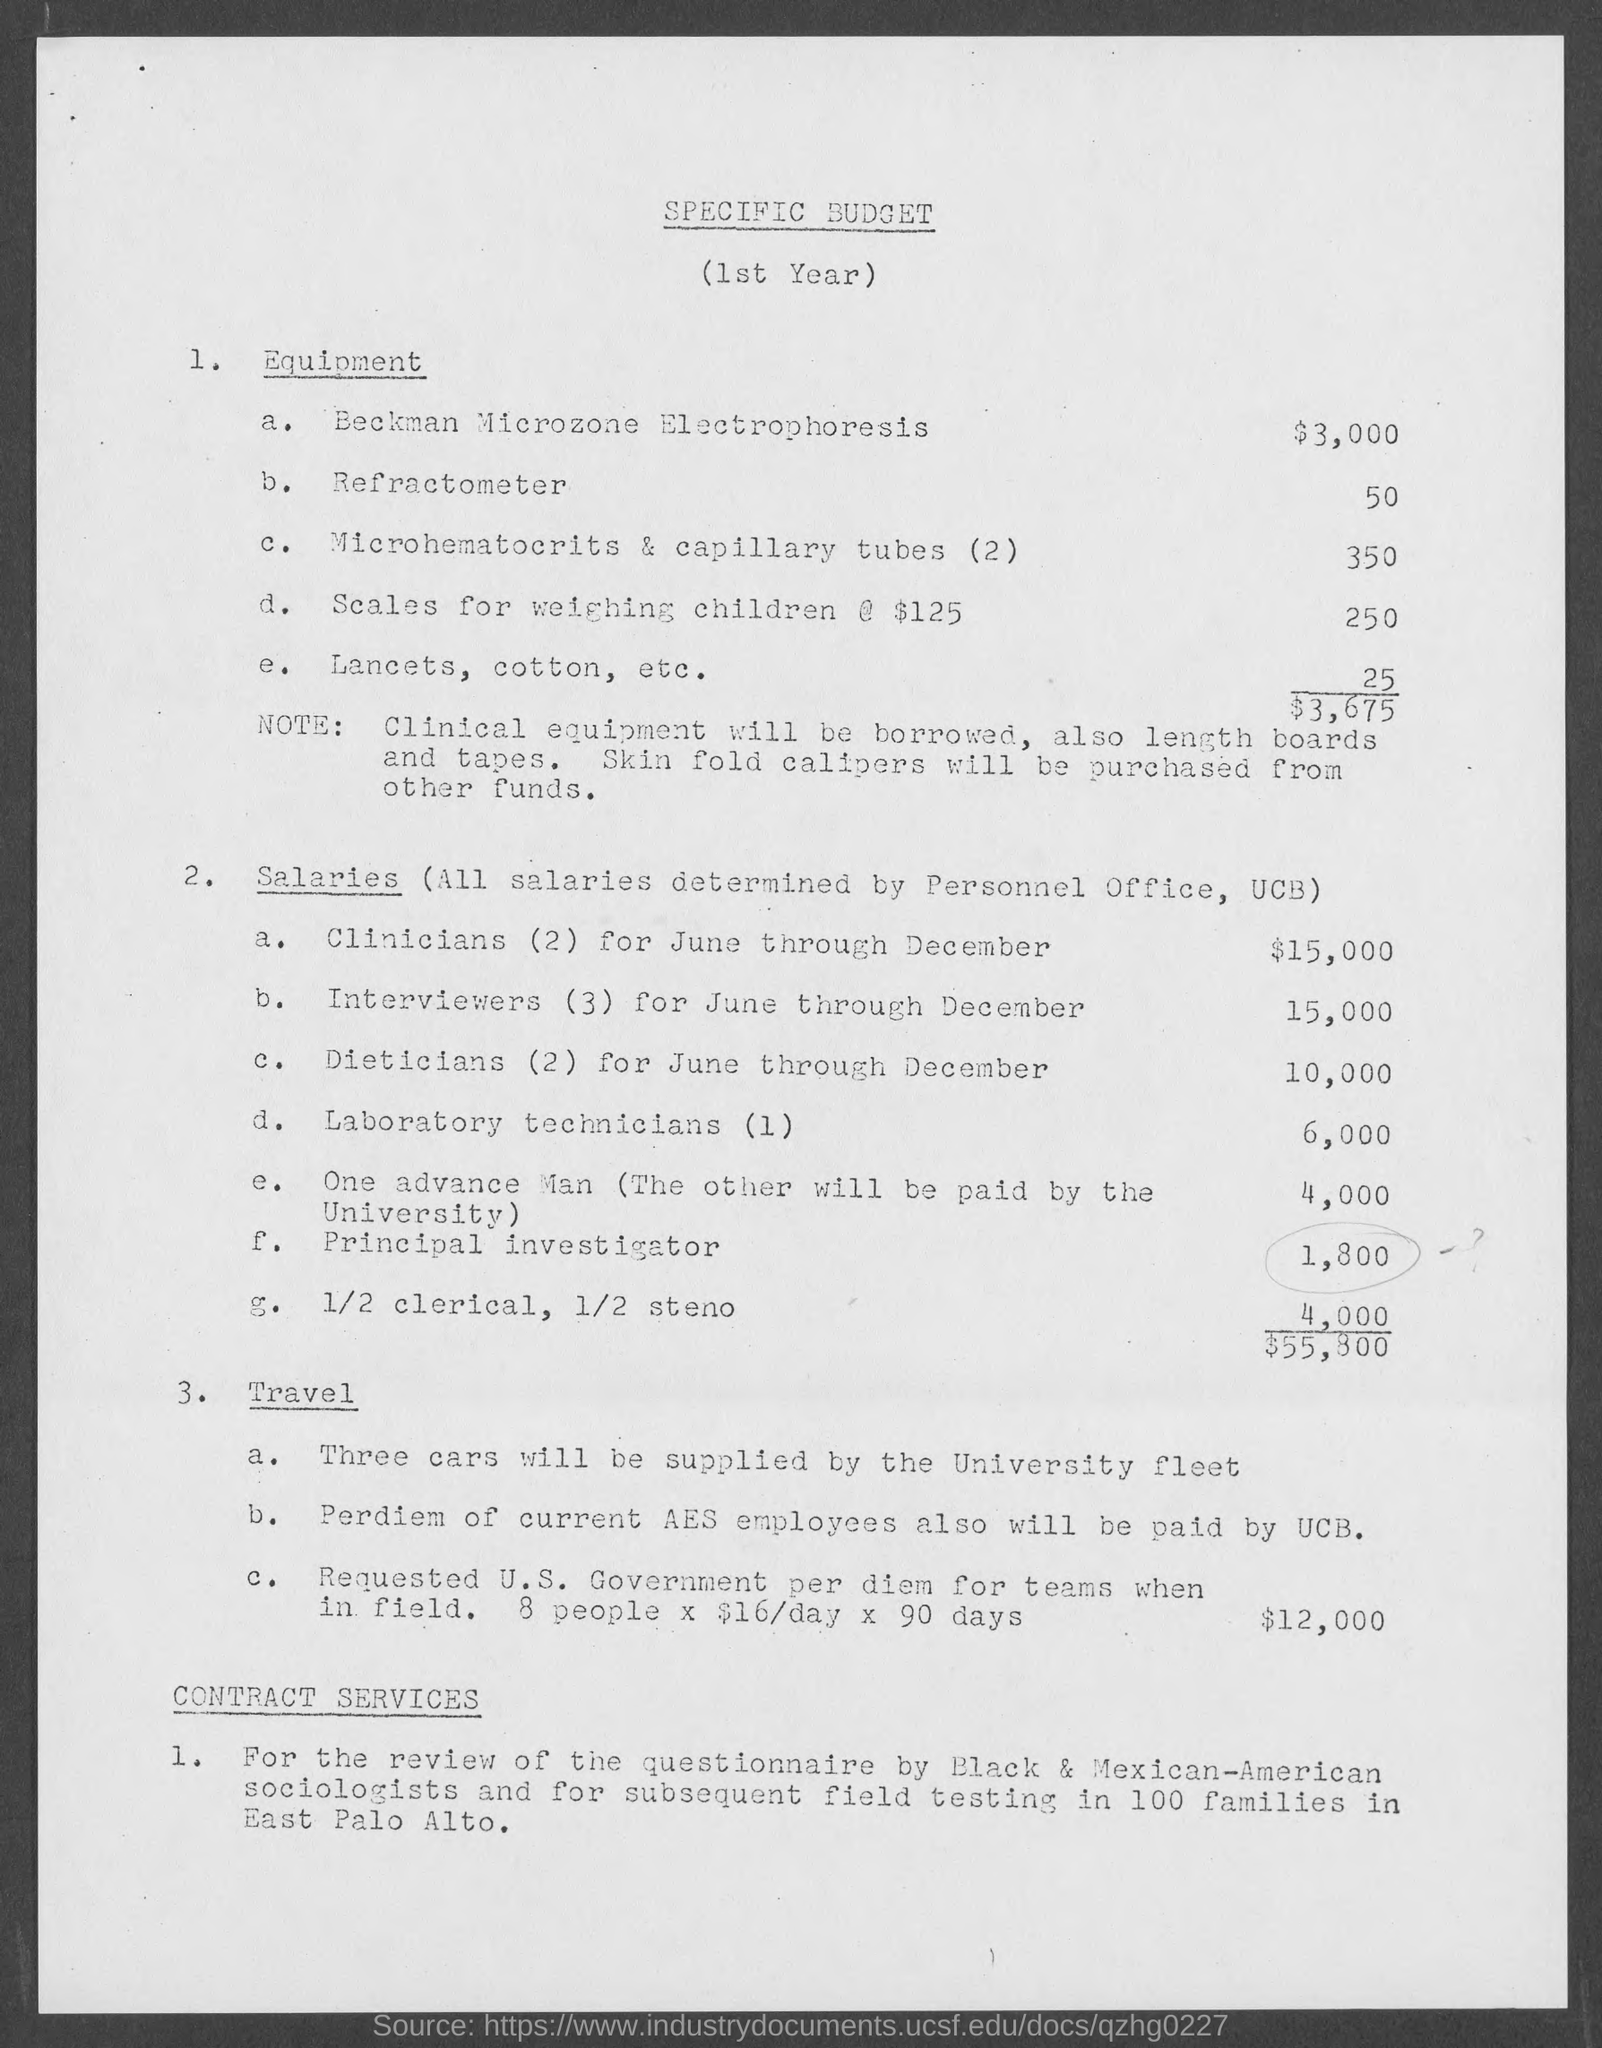Can you tell me more about the travel expenses outlined in the document? Of course. The travel section details the provision of three cars by the University fleet, covering per diem for current AES employees paid by UCB, and a requested U.S. Government per diem for teams in the field, which amounts to 8 people x $16/day x 90 days, summing up to a total of $12,000. 